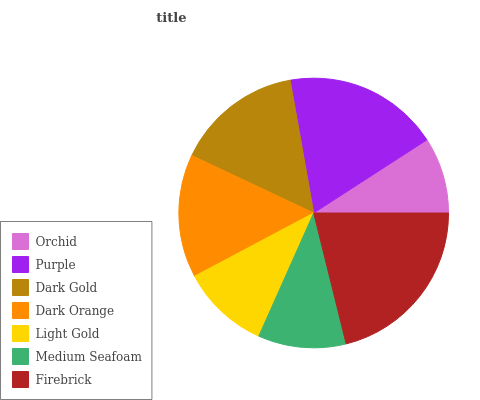Is Orchid the minimum?
Answer yes or no. Yes. Is Firebrick the maximum?
Answer yes or no. Yes. Is Purple the minimum?
Answer yes or no. No. Is Purple the maximum?
Answer yes or no. No. Is Purple greater than Orchid?
Answer yes or no. Yes. Is Orchid less than Purple?
Answer yes or no. Yes. Is Orchid greater than Purple?
Answer yes or no. No. Is Purple less than Orchid?
Answer yes or no. No. Is Dark Orange the high median?
Answer yes or no. Yes. Is Dark Orange the low median?
Answer yes or no. Yes. Is Orchid the high median?
Answer yes or no. No. Is Medium Seafoam the low median?
Answer yes or no. No. 